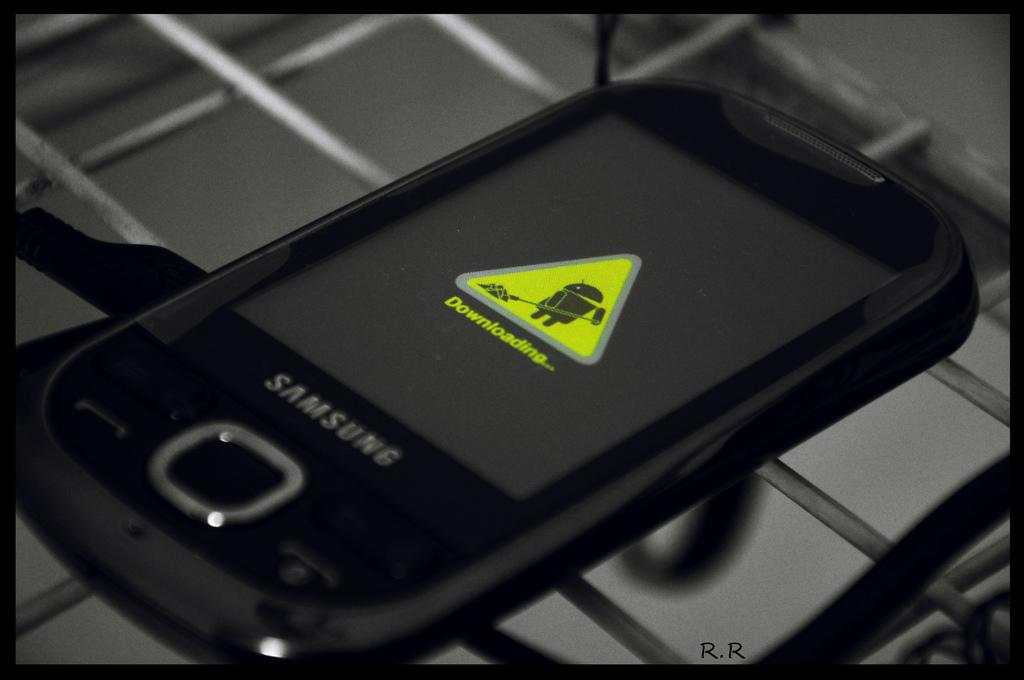Provide a one-sentence caption for the provided image. The front of a Samsung phone indicates that it is downloading something. 